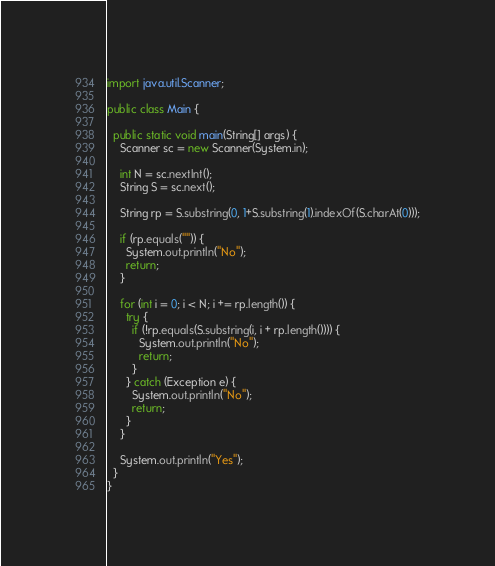<code> <loc_0><loc_0><loc_500><loc_500><_Java_>import java.util.Scanner;

public class Main {

  public static void main(String[] args) {
    Scanner sc = new Scanner(System.in);

    int N = sc.nextInt();
    String S = sc.next();

    String rp = S.substring(0, 1+S.substring(1).indexOf(S.charAt(0)));

    if (rp.equals("")) {
      System.out.println("No");
      return; 
    }

    for (int i = 0; i < N; i += rp.length()) {
      try {
        if (!rp.equals(S.substring(i, i + rp.length()))) {
          System.out.println("No");
          return;   
        }
      } catch (Exception e) {
        System.out.println("No");
        return; 
      }
    }
    
    System.out.println("Yes");
  }
}</code> 